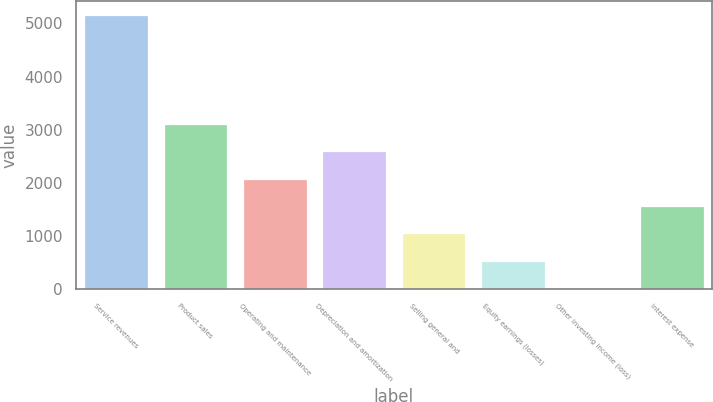Convert chart. <chart><loc_0><loc_0><loc_500><loc_500><bar_chart><fcel>Service revenues<fcel>Product sales<fcel>Operating and maintenance<fcel>Depreciation and amortization<fcel>Selling general and<fcel>Equity earnings (losses)<fcel>Other investing income (loss)<fcel>Interest expense<nl><fcel>5164<fcel>3109.2<fcel>2081.8<fcel>2595.5<fcel>1054.4<fcel>540.7<fcel>27<fcel>1568.1<nl></chart> 